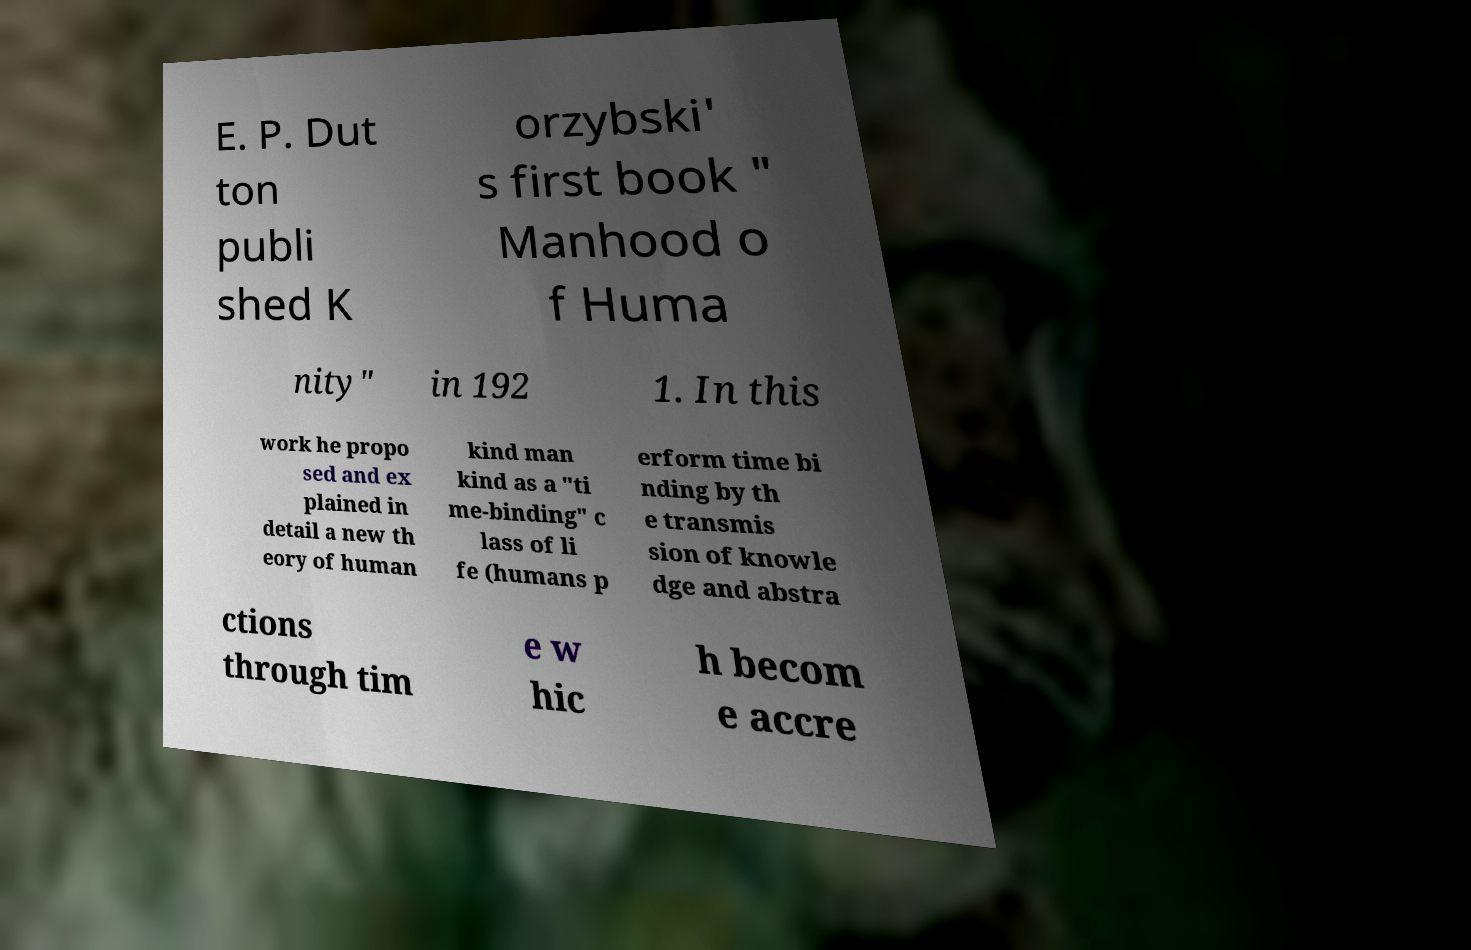Can you accurately transcribe the text from the provided image for me? E. P. Dut ton publi shed K orzybski' s first book " Manhood o f Huma nity" in 192 1. In this work he propo sed and ex plained in detail a new th eory of human kind man kind as a "ti me-binding" c lass of li fe (humans p erform time bi nding by th e transmis sion of knowle dge and abstra ctions through tim e w hic h becom e accre 